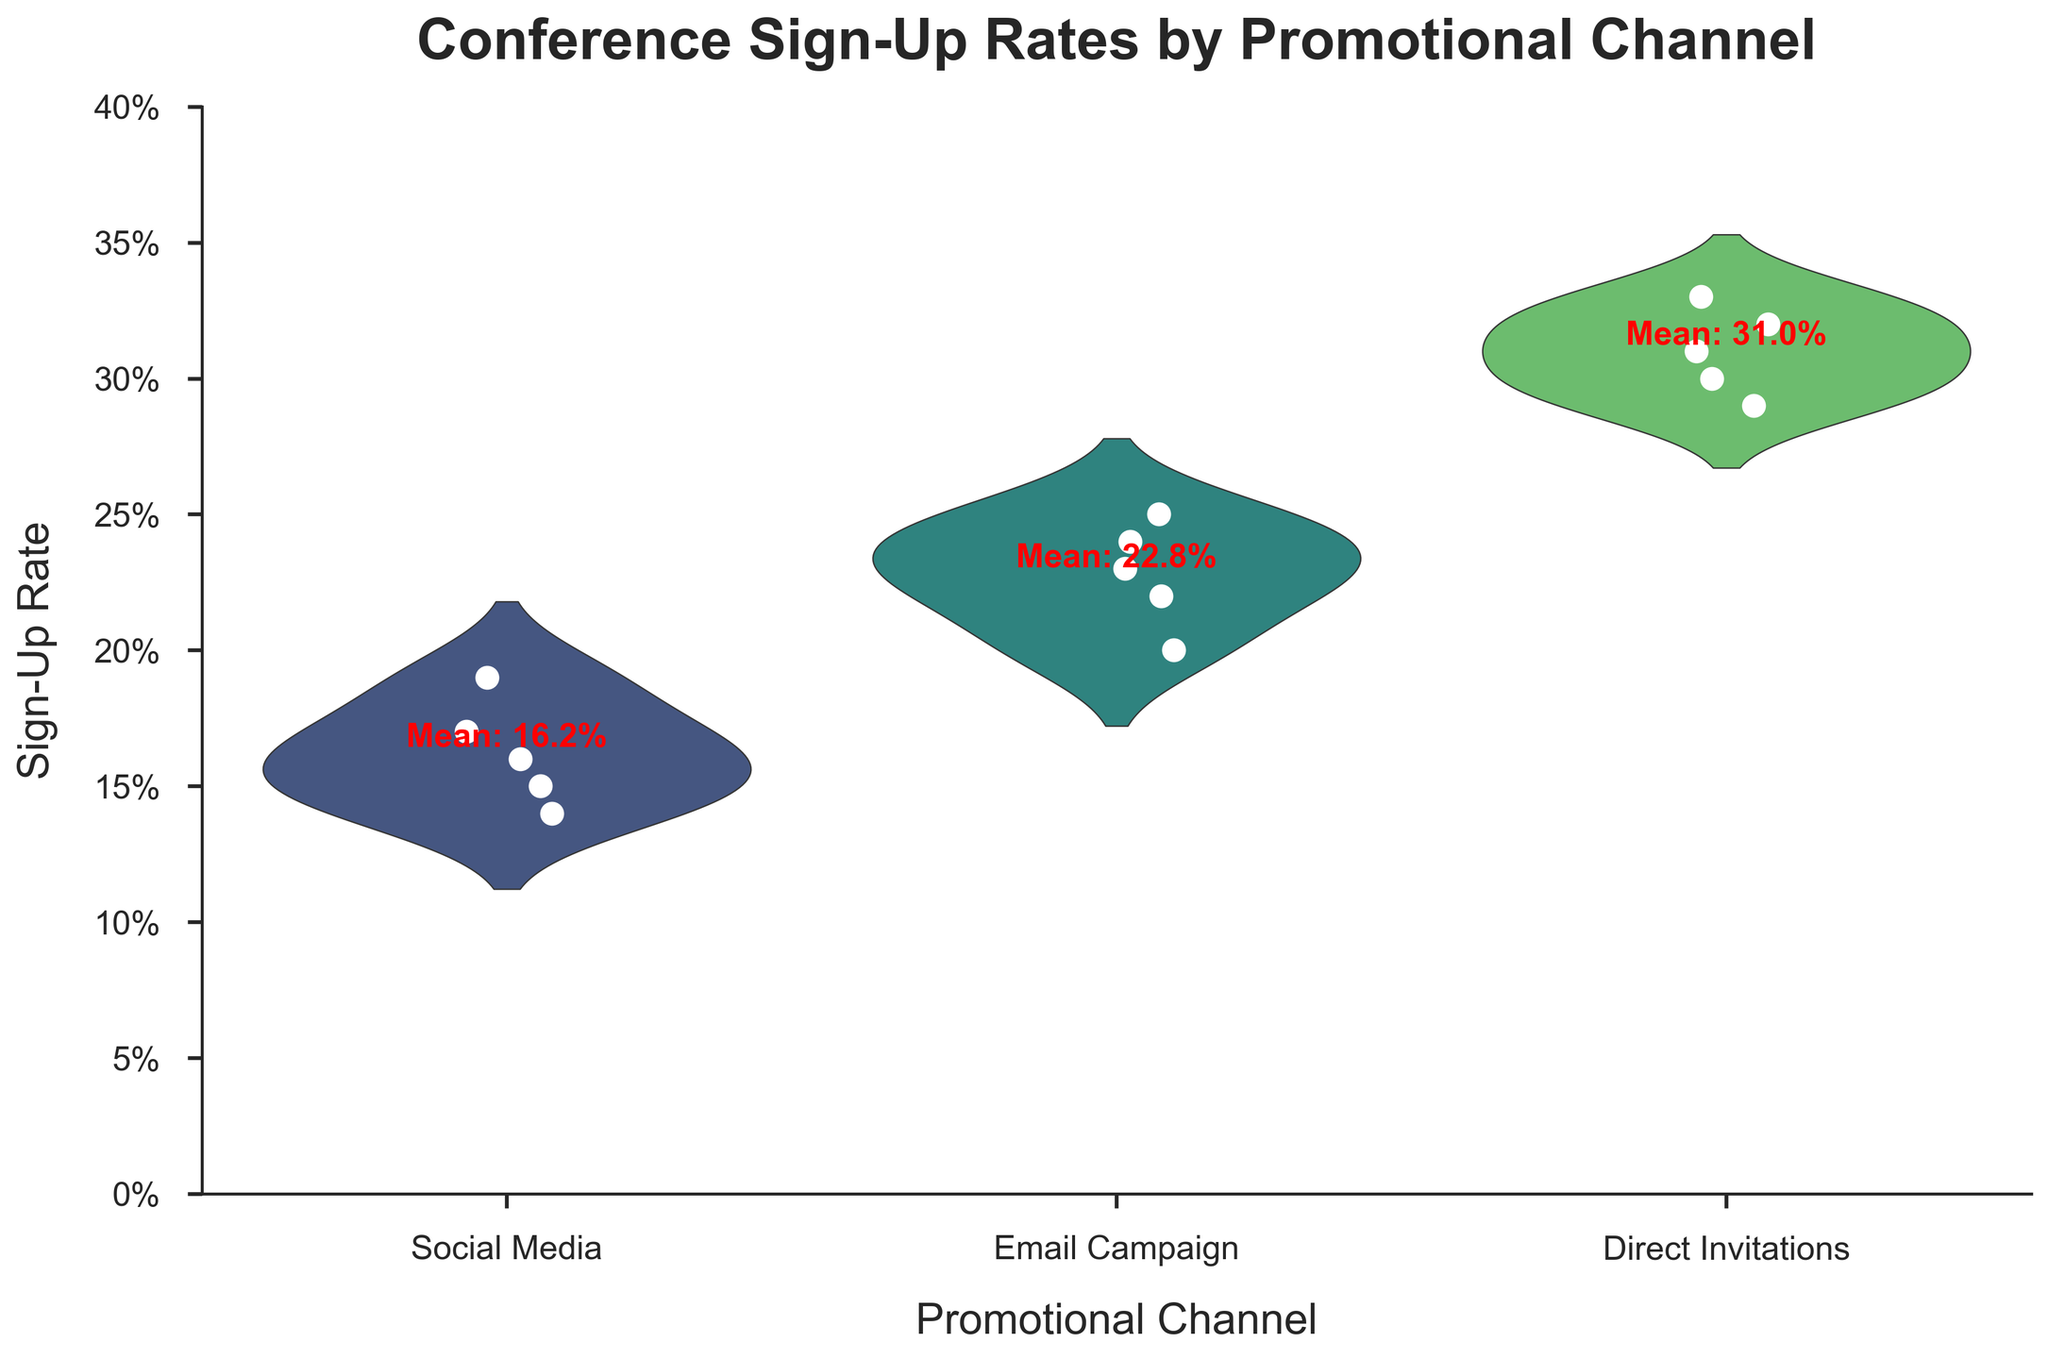What is the title of the chart? The title of the chart is at the top and reads "Conference Sign-Up Rates by Promotional Channel."
Answer: Conference Sign-Up Rates by Promotional Channel How many different promotional channels are displayed on the chart? The x-axis categorizes three different promotional channels: Social Media, Email Campaigns, and Direct Invitations.
Answer: Three Which promotional channel shows the highest average sign-up rate? The text indicating the mean sign-up rate for each channel shows that Direct Invitations has the highest mean rate.
Answer: Direct Invitations What is the mean sign-up rate for Email Campaigns? The mean sign-up rate for Email Campaigns is directly labeled on the chart and reads "Mean: 22.8%."
Answer: 22.8% What is the range of sign-up rates for the Social Media channel? The lower bound of the violin plot for Social Media is around 14%, and the upper bound is around 19%.
Answer: 14% to 19% Which promotional channel has the most spread in the sign-up rates? By comparing the shapes of the violin plots, Direct Invitations has the widest spread in sign-up rates.
Answer: Direct Invitations Which channel has the lowest individual sign-up rate point? By observing the jittered points in each violin plot, Social Media has the lowest individual sign-up rate at around 14%.
Answer: Social Media How do sign-up rates from Direct Invitations compare to Email Campaigns? Direct Invitations has a higher mean sign-up rate and a wider spread of individual points compared to Email Campaigns.
Answer: Higher and wider spread What are the approximate upper and lower values for the sign-up rates of Email Campaigns? The upper value for Email Campaigns is around 25%, and the lower value is around 20%.
Answer: 20% to 25% 